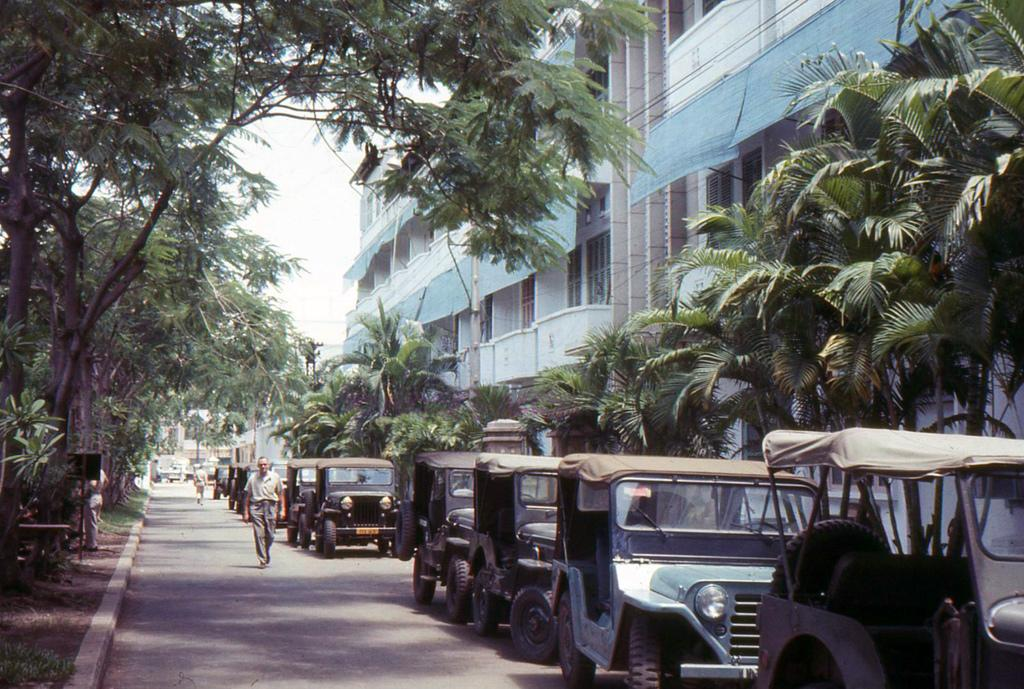Who or what can be seen in the image? There are people in the image. What else is present in the image besides people? There are vehicles on the road and trees on both sides of the road in the image. What can be seen in the background of the image? There is a building and the sky visible in the background of the image. What type of rat can be seen talking to the people in the image? There is no rat present in the image, and no one is talking to the people in the image. 